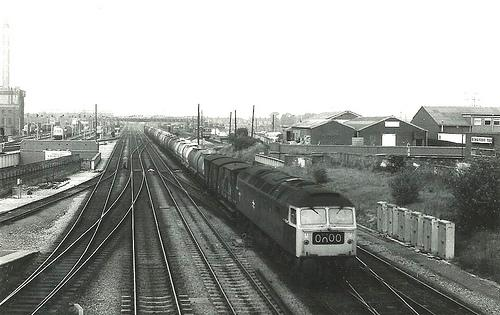What objects can you find on the train's windows, and what are their sizes? Windshield wipers on the train (Width: 35, Height: 35), the windshield of the train (Width: 52, Height: 52), front windows to the train (Width: 61, Height: 61), and side window to the train (Width: 19, Height: 19). What material are the train tracks made of, and what surrounds them? The train tracks are made of metal and wood, and there is gravel around the tracks. List some objects found in the distance that are related to the train. Storage buildings, a brick building, electrical boxes, a pole, and a tree are objects found in the distance related to the train. Explain the type of landscape in the image and the position of the train. The image presents a grassy landscape with several train tracks in the foreground, and a long train is on one of the tracks, moving parallel with the other tracks. Provide a brief description of the image's subject focusing on transportation. The image's subject is focused on a train that is on the tracks, with several railroad tracks on the ground, and train tracks splitting off in different directions. Identify three types of vegetation found in the image and their approximate sizes. A small bush near the train (Width: 36, Height: 36), a large bush (Width: 44, Height: 44), and a larger bush near the small bush (Width: 56, Height: 56). How many cars are attached to the train, according to the image? The train has 7 cars attached to it. Describe the placement and appearance of the sign featured in the image. A white sign is present on a brick building, located near the right edge of the image, and it measures 35 units in width and height. Identify the structures and objects near the train track that may be part of infrastructure. The platform off the track, electrical boxes on the side of the track, a fence next to a building, and a tower on the side are infrastructure objects near the train track. 